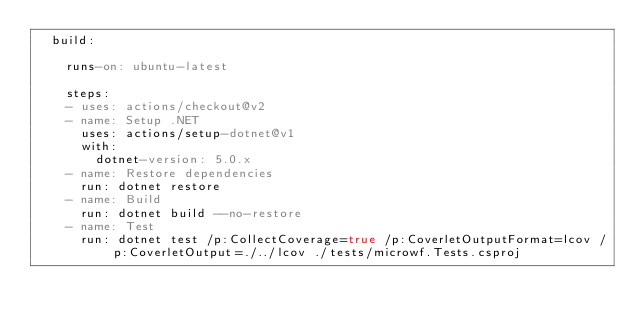<code> <loc_0><loc_0><loc_500><loc_500><_YAML_>  build:

    runs-on: ubuntu-latest

    steps:
    - uses: actions/checkout@v2
    - name: Setup .NET
      uses: actions/setup-dotnet@v1
      with:
        dotnet-version: 5.0.x
    - name: Restore dependencies
      run: dotnet restore
    - name: Build
      run: dotnet build --no-restore
    - name: Test
      run: dotnet test /p:CollectCoverage=true /p:CoverletOutputFormat=lcov /p:CoverletOutput=./../lcov ./tests/microwf.Tests.csproj
</code> 